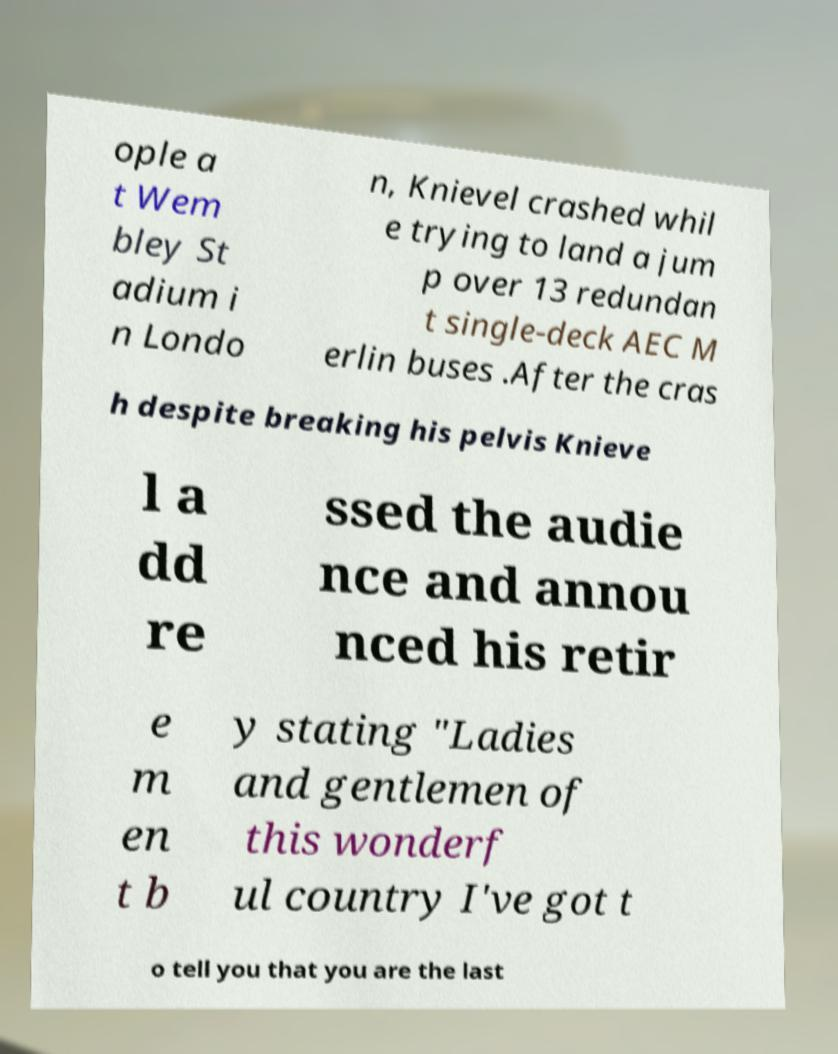What messages or text are displayed in this image? I need them in a readable, typed format. ople a t Wem bley St adium i n Londo n, Knievel crashed whil e trying to land a jum p over 13 redundan t single-deck AEC M erlin buses .After the cras h despite breaking his pelvis Knieve l a dd re ssed the audie nce and annou nced his retir e m en t b y stating "Ladies and gentlemen of this wonderf ul country I've got t o tell you that you are the last 